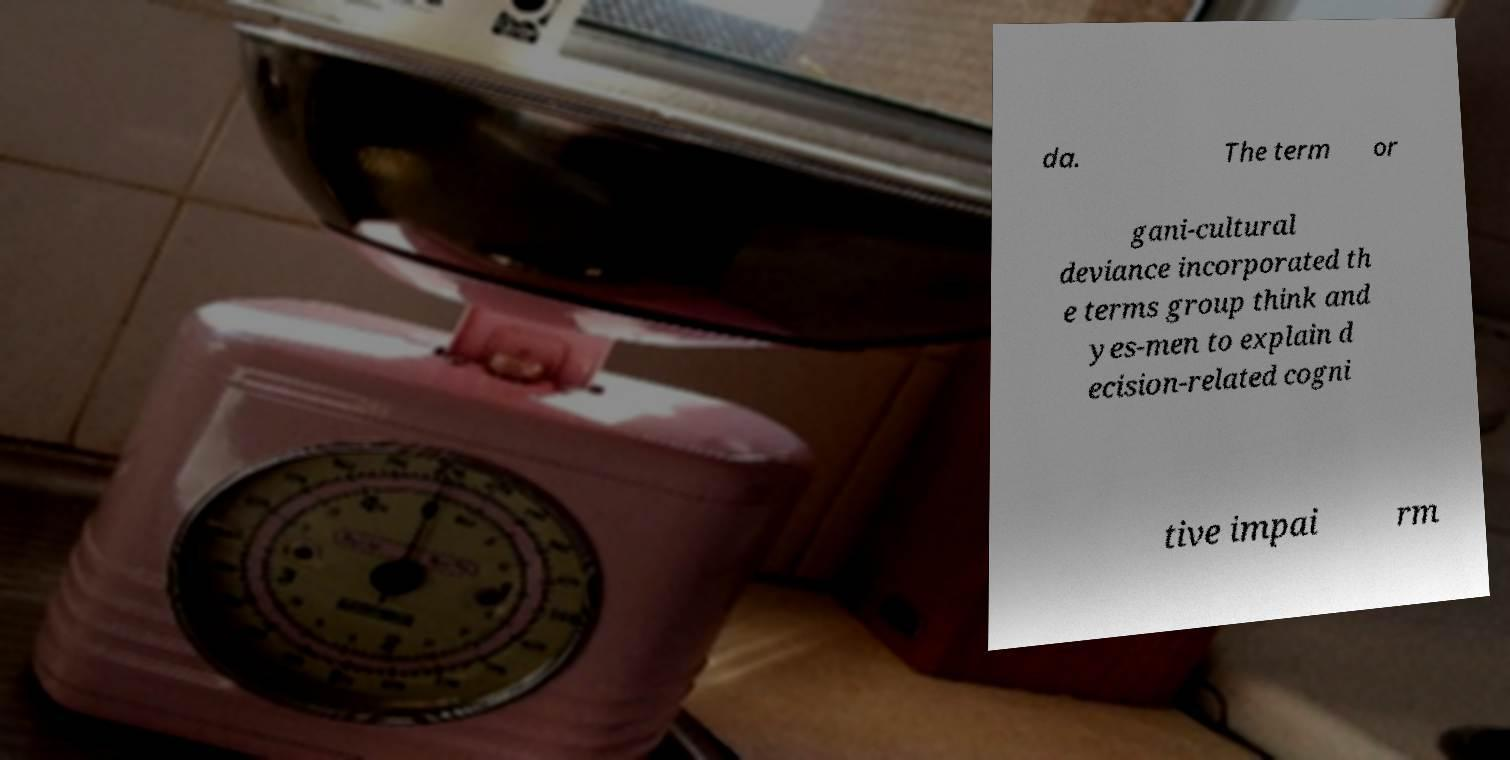I need the written content from this picture converted into text. Can you do that? da. The term or gani-cultural deviance incorporated th e terms group think and yes-men to explain d ecision-related cogni tive impai rm 